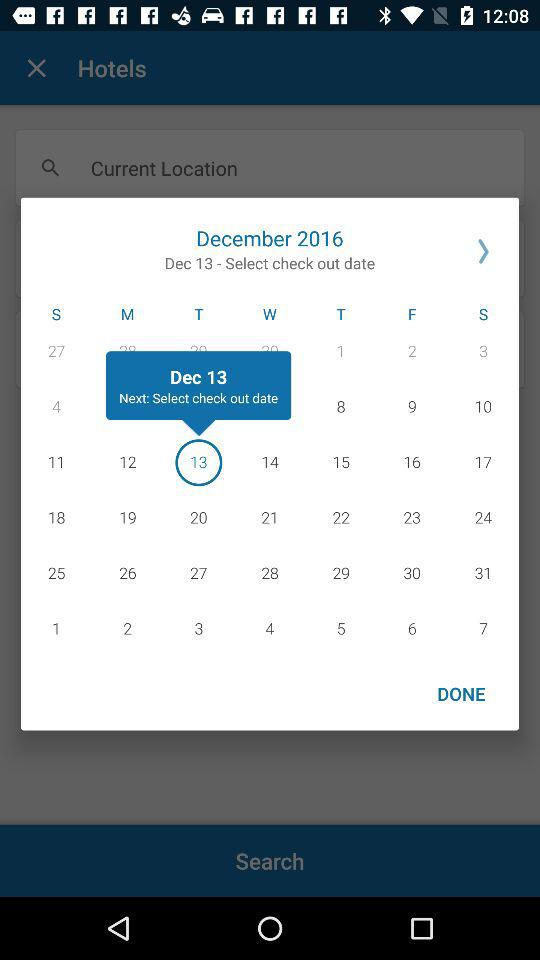What day is it on the selected date? The selected day is Tuesday. 